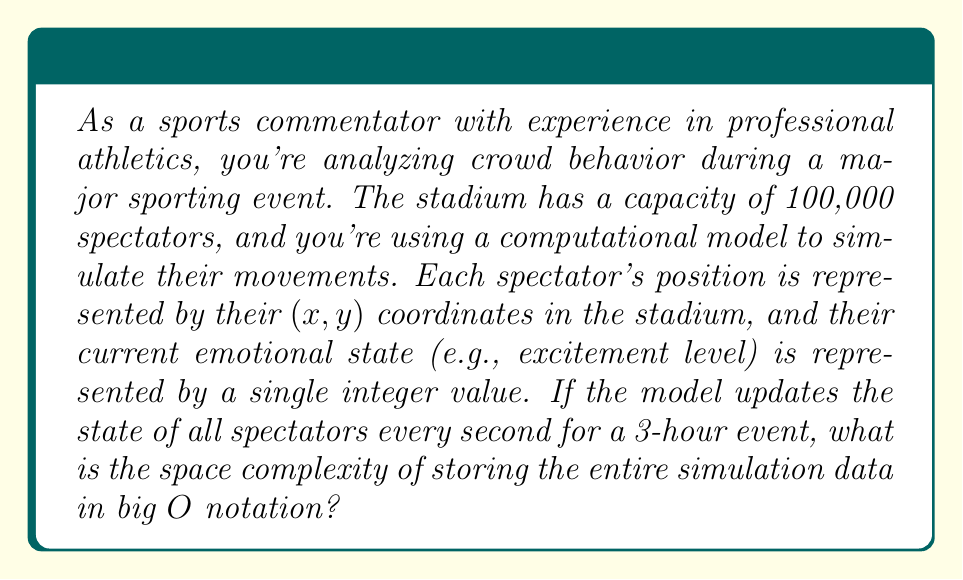What is the answer to this math problem? Let's break this down step-by-step:

1) First, we need to consider what data we're storing for each spectator:
   - x-coordinate (1 value)
   - y-coordinate (1 value)
   - emotional state (1 value)
   Total: 3 values per spectator

2) Now, let's look at the total number of spectators:
   $n = 100,000$

3) For each time step, we store 3 values for each of the n spectators:
   $3n$ values per time step

4) Now, let's calculate the number of time steps:
   - The event lasts 3 hours = 180 minutes = 10,800 seconds
   - We update every second
   So, there are 10,800 time steps

5) Total number of values stored:
   $$ 3n * 10,800 = 32,400n $$

6) In big O notation, we drop constants, so this simplifies to $O(n)$

The key insight here is that even though we're storing a large amount of data over time, the space complexity is still linear with respect to the number of spectators. This is because the number of time steps is a constant (10,800) and doesn't change with n.

From a sports psychology perspective, this model allows us to track how the emotional state of the crowd evolves over time, which could provide valuable insights into team performance and home-field advantage.
Answer: $O(n)$, where n is the number of spectators 